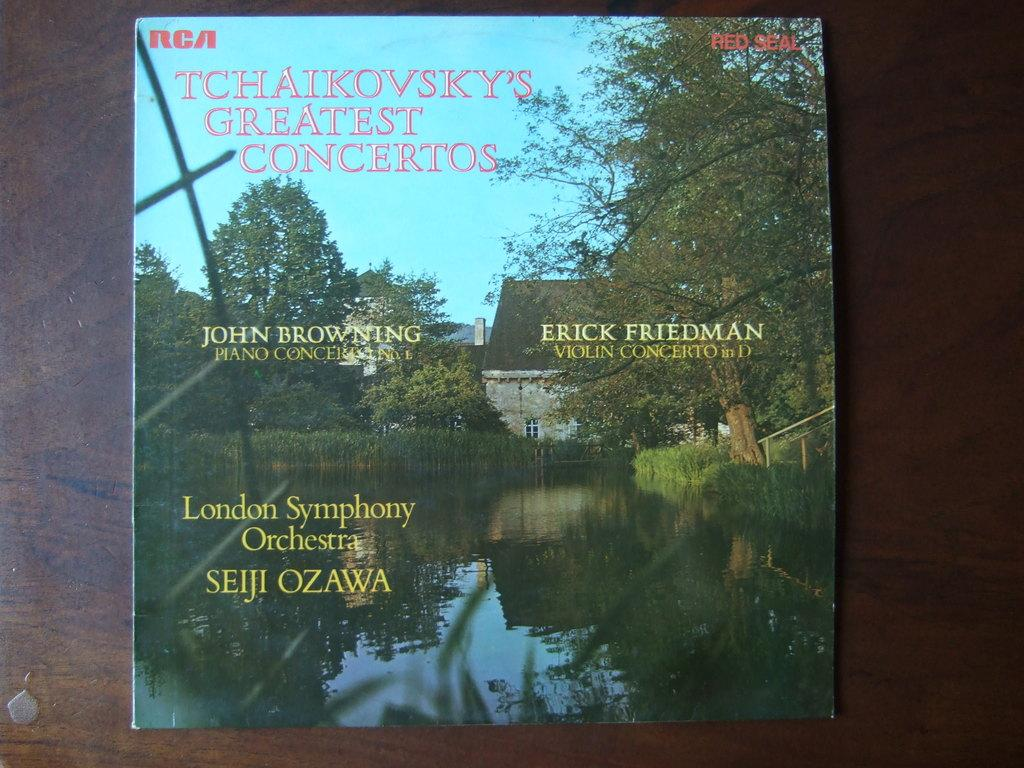<image>
Summarize the visual content of the image. A music record of Tchaikovsky's greatest hits featuring Seji Ozawa. 